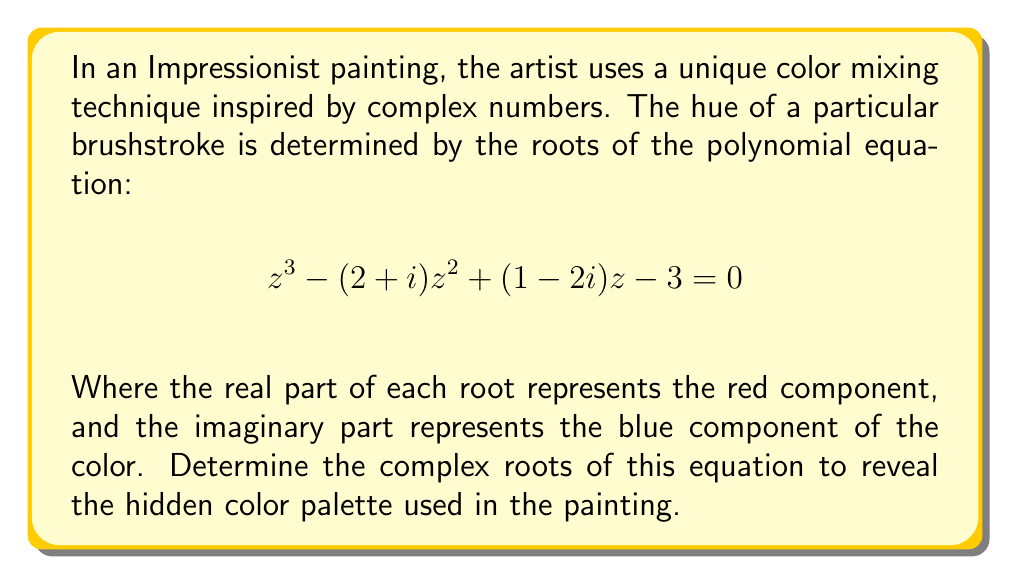Solve this math problem. To solve this cubic equation, we can use the following steps:

1) First, let's identify the coefficients:
   $a = 1$, $b = -(2+i)$, $c = 1-2i$, $d = -3$

2) We'll use Cardano's formula for cubic equations. Let's define:
   $$p = \frac{3ac-b^2}{3a^2}$$
   $$q = \frac{2b^3-9abc+27a^2d}{27a^3}$$

3) Calculating $p$:
   $$p = \frac{3(1)(1-2i)-(-2-i)^2}{3(1)^2} = \frac{3-6i-4-4i+1}{3} = -1-\frac{10}{3}i$$

4) Calculating $q$:
   $$q = \frac{2(-2-i)^3-9(1)(-2-i)(1-2i)+27(1)^2(-3)}{27(1)^3}$$
   $$= \frac{-16-24i+18+36i-81}{27} = -\frac{79}{27}-\frac{4}{9}i$$

5) Now, we calculate:
   $$u = \sqrt[3]{-\frac{q}{2}+\sqrt{\frac{q^2}{4}+\frac{p^3}{27}}}$$
   $$v = \sqrt[3]{-\frac{q}{2}-\sqrt{\frac{q^2}{4}+\frac{p^3}{27}}}$$

6) The roots are then given by:
   $$z_1 = u + v - \frac{b}{3a}$$
   $$z_2 = \omega u + \omega^2 v - \frac{b}{3a}$$
   $$z_3 = \omega^2 u + \omega v - \frac{b}{3a}$$

   where $\omega = -\frac{1}{2}+i\frac{\sqrt{3}}{2}$ is a cube root of unity.

7) Calculating these values numerically (as the exact form is very complex):

   $z_1 \approx 2.4149 + 0.5056i$
   $z_2 \approx -0.2074 + 1.2472i$
   $z_3 \approx -0.2074 - 0.7528i$

These complex roots represent the color palette used in the painting.
Answer: The complex roots of the equation are approximately:
$z_1 \approx 2.4149 + 0.5056i$
$z_2 \approx -0.2074 + 1.2472i$
$z_3 \approx -0.2074 - 0.7528i$ 